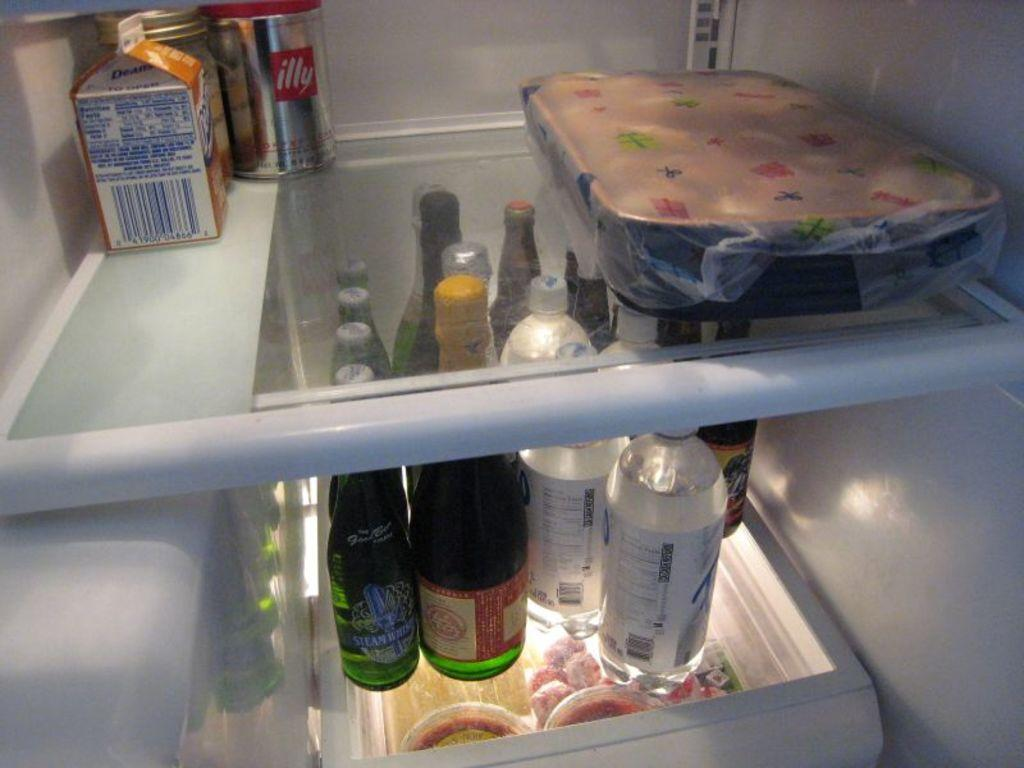<image>
Render a clear and concise summary of the photo. A refrigerator with a casserole dish, a few bottles, and a silver can labeled "illy" in the background. 